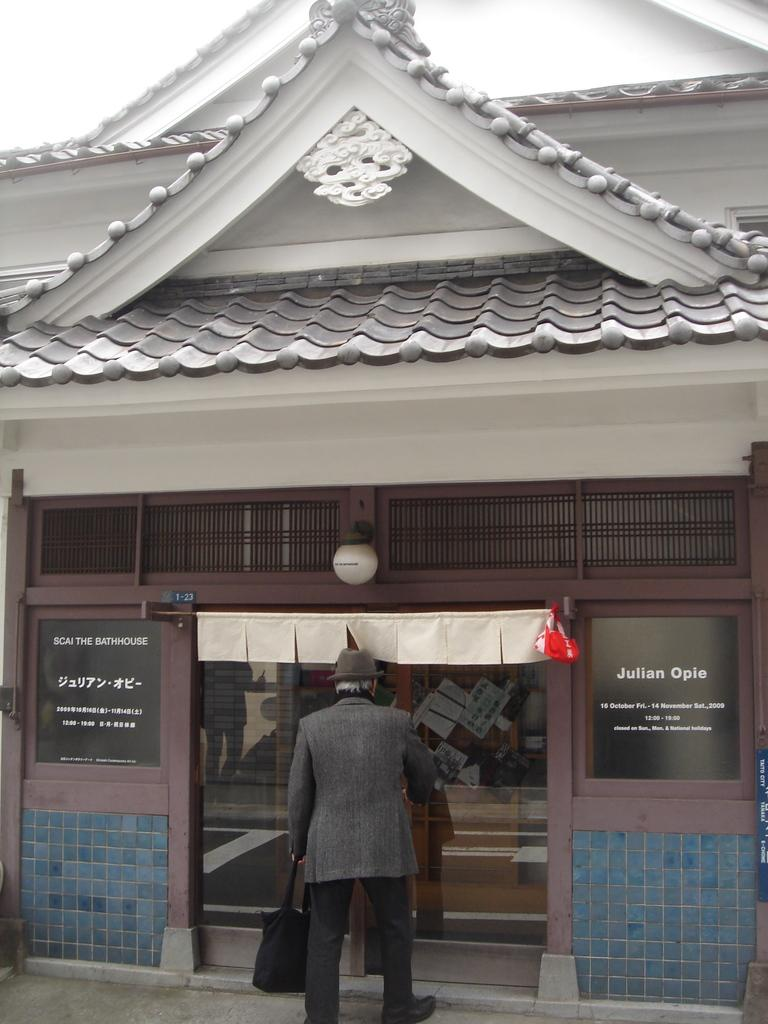What type of structure is visible in the image? There is a building in the image. What feature of the building is mentioned in the facts? There is a glass door in the image. What is the person in the image carrying? The person is holding a bag in the image. How is the person dressed? The person is wearing an ash and black color dress and a hat. What type of tent can be seen in the image? There is no tent present in the image. What news is being reported by the person in the image? The image does not show any news being reported or any indication of the person's profession or activity related to news. 